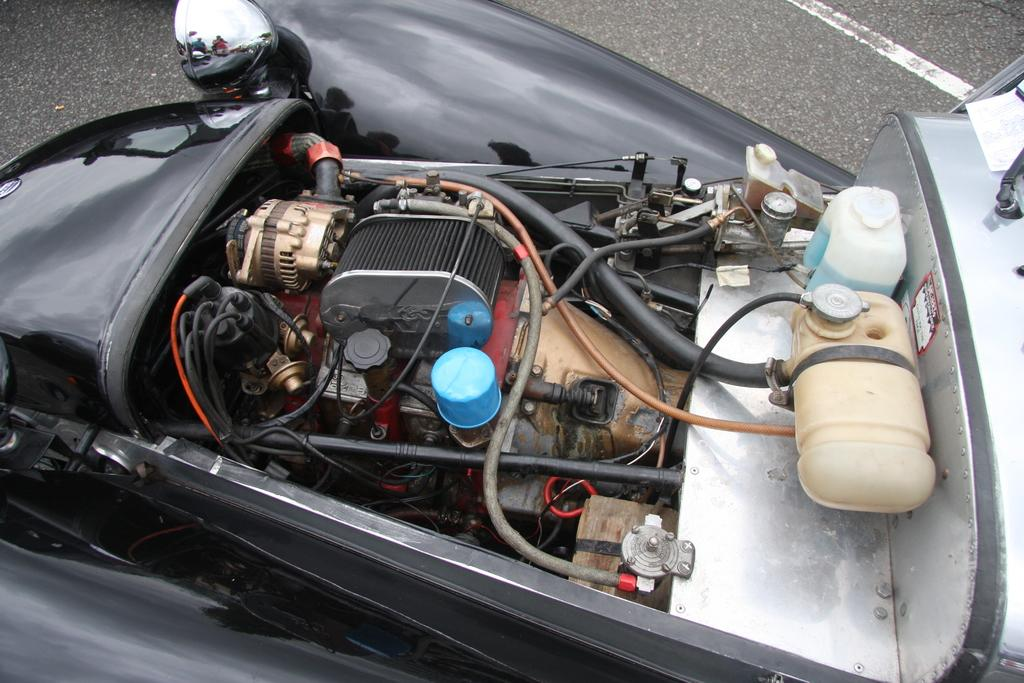What is the main subject of the image? The main subject of the image is a vehicle. Where is the vehicle located? The vehicle is on the road. What can be seen on the vehicle? There are machines and cables on the vehicle. What type of dinosaurs can be seen in the image? There are no dinosaurs present in the image; it features a vehicle on the road with machines and cables. Can you tell me how many baskets are attached to the vehicle? There are no baskets attached to the vehicle in the image. 